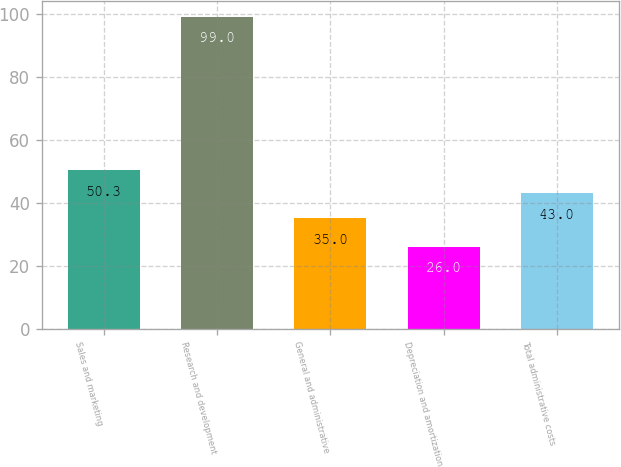Convert chart to OTSL. <chart><loc_0><loc_0><loc_500><loc_500><bar_chart><fcel>Sales and marketing<fcel>Research and development<fcel>General and administrative<fcel>Depreciation and amortization<fcel>Total administrative costs<nl><fcel>50.3<fcel>99<fcel>35<fcel>26<fcel>43<nl></chart> 